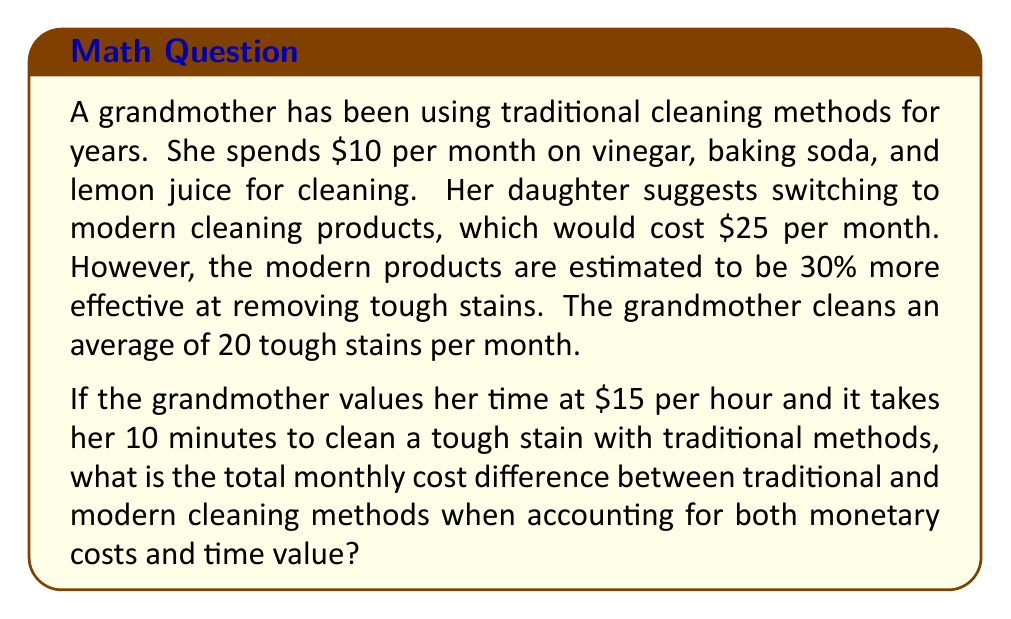What is the answer to this math problem? Let's break this problem down step-by-step:

1. Calculate the time spent cleaning with traditional methods:
   - Time per stain = 10 minutes = 1/6 hour
   - Total time = 20 stains × 1/6 hour = 10/3 hours

2. Calculate the time value of traditional cleaning:
   - Time value = (10/3 hours) × $15/hour = $50

3. Calculate the total cost of traditional cleaning:
   - Total cost = Material cost + Time value
   - Total cost = $10 + $50 = $60

4. Calculate the time spent cleaning with modern methods:
   - Modern methods are 30% more effective, so they take 70% of the time
   - Time with modern methods = (10/3 hours) × 0.7 = 7/3 hours

5. Calculate the time value of modern cleaning:
   - Time value = (7/3 hours) × $15/hour = $35

6. Calculate the total cost of modern cleaning:
   - Total cost = Material cost + Time value
   - Total cost = $25 + $35 = $60

7. Calculate the difference in total monthly cost:
   - Difference = Traditional cost - Modern cost
   - Difference = $60 - $60 = $0

Therefore, when accounting for both monetary costs and time value, there is no difference in the total monthly cost between traditional and modern cleaning methods.
Answer: $0 